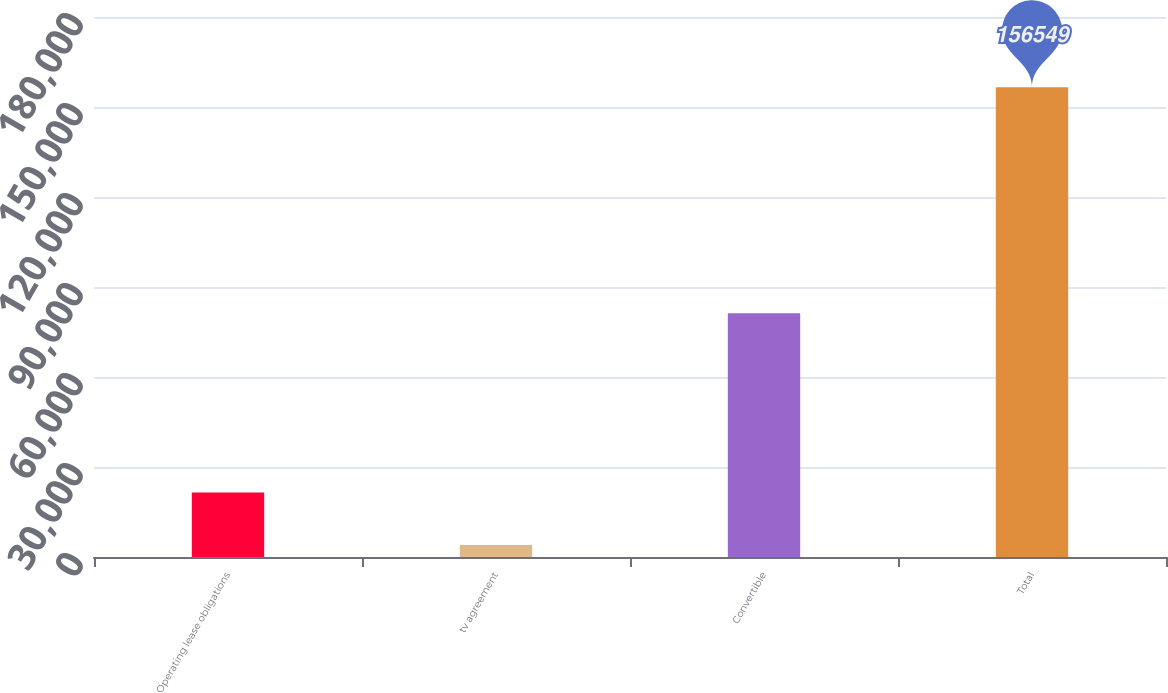Convert chart to OTSL. <chart><loc_0><loc_0><loc_500><loc_500><bar_chart><fcel>Operating lease obligations<fcel>tv agreement<fcel>Convertible<fcel>Total<nl><fcel>21502<fcel>4000<fcel>81250<fcel>156549<nl></chart> 